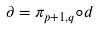<formula> <loc_0><loc_0><loc_500><loc_500>\partial = \pi _ { p + 1 , q } \circ d</formula> 